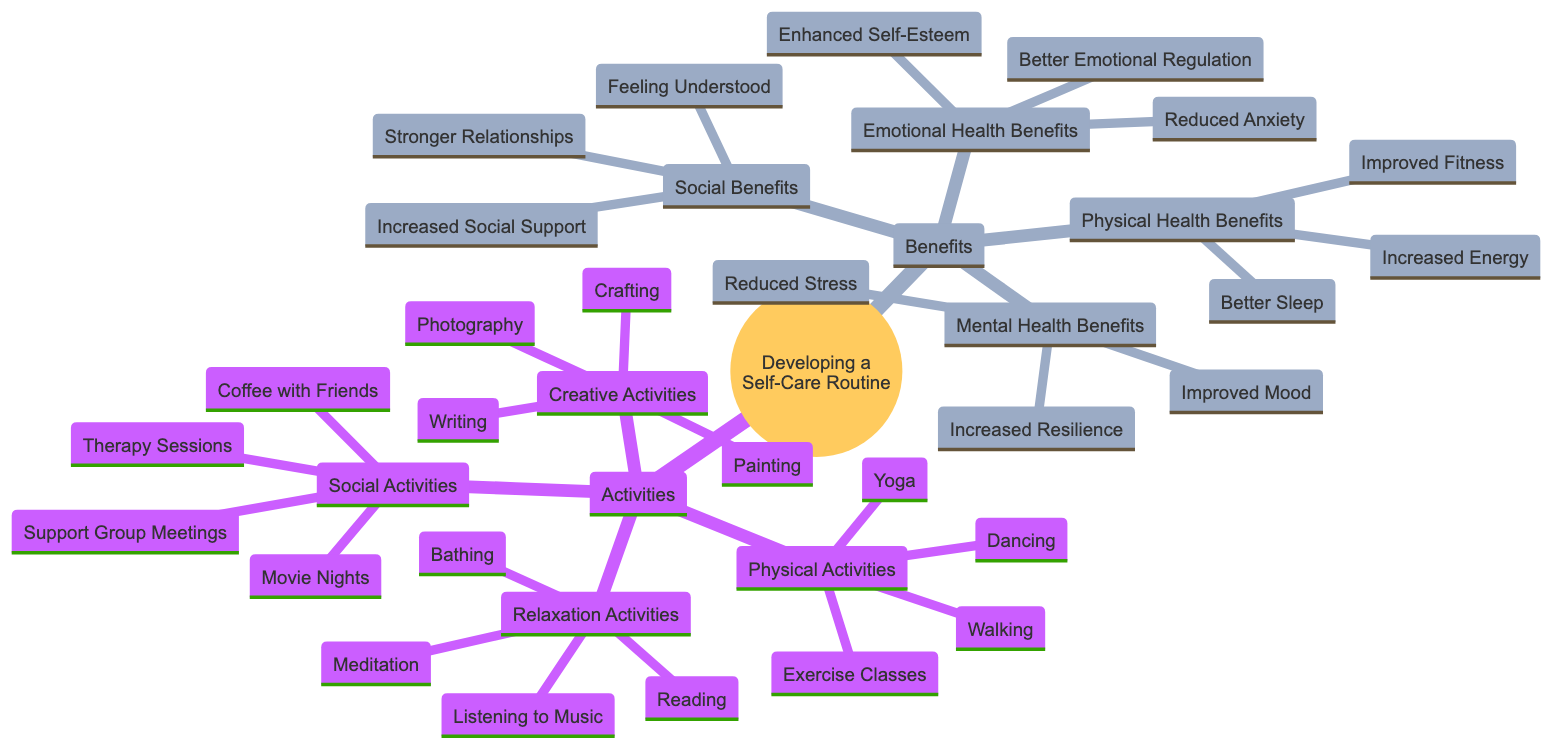What are the four categories of activities listed in the diagram? The diagram lists four categories of activities: Physical Activities, Creative Activities, Relaxation Activities, and Social Activities. Each of these categories contains specific activities under them.
Answer: Physical Activities, Creative Activities, Relaxation Activities, Social Activities How many activities are under Creative Activities? The Creative Activities category contains four activities: Painting, Writing, Crafting, and Photography. Counting these gives the total number of activities.
Answer: 4 What is one benefit of engaging in Social Activities? The diagram lists several benefits related to Social Activities, including Stronger Relationships, Increased Social Support, and Feeling Understood. Any of these counts as a valid answer.
Answer: Stronger Relationships Which activity is listed under Relaxation Activities? The diagram includes various activities under Relaxation Activities, such as Meditation, Reading, Bathing, and Listening to Music. Any one of these activities answers the question.
Answer: Meditation What are the three categories of benefits shown in the diagram? The benefits are divided into four categories: Physical Health Benefits, Mental Health Benefits, Emotional Health Benefits, and Social Benefits. The question asks for three, so we can select any three of these categories.
Answer: Physical Health Benefits, Mental Health Benefits, Emotional Health Benefits Which activity can help with Better Sleep? Among the activities listed, Physical Activities like Walking can contribute to Better Sleep. Referencing the connection of benefits to specific activities in the diagram reveals this relationship.
Answer: Walking What is a Mental Health Benefit listed in the diagram? The diagram provides several Mental Health Benefits, including Reduced Stress, Improved Mood, and Increased Resilience. Any of these benefits would be a correct response.
Answer: Reduced Stress Which specific activity in the diagram is related to better emotional regulation? While the benefits related to better emotional regulation include Better Emotional Regulation, the associated activities are not directly specified for this benefit; however, activities like Creative Activities could enhance emotional regulation, making Writing a reasonable choice.
Answer: Writing What type of diagram is this representation known as? The diagram is a Concept Map, typically used to visually organize and structure information, demonstrating relationships between different concepts like activities and benefits.
Answer: Concept Map 